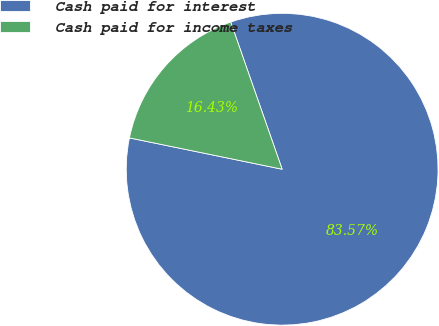Convert chart to OTSL. <chart><loc_0><loc_0><loc_500><loc_500><pie_chart><fcel>Cash paid for interest<fcel>Cash paid for income taxes<nl><fcel>83.57%<fcel>16.43%<nl></chart> 